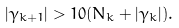<formula> <loc_0><loc_0><loc_500><loc_500>| \gamma _ { k + 1 } | > 1 0 ( N _ { k } + | \gamma _ { k } | ) .</formula> 